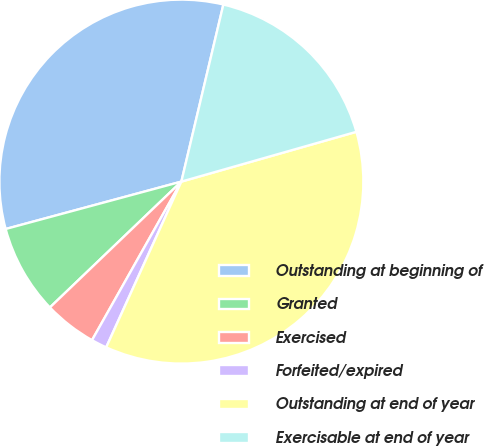Convert chart. <chart><loc_0><loc_0><loc_500><loc_500><pie_chart><fcel>Outstanding at beginning of<fcel>Granted<fcel>Exercised<fcel>Forfeited/expired<fcel>Outstanding at end of year<fcel>Exercisable at end of year<nl><fcel>32.9%<fcel>7.96%<fcel>4.68%<fcel>1.39%<fcel>36.19%<fcel>16.88%<nl></chart> 